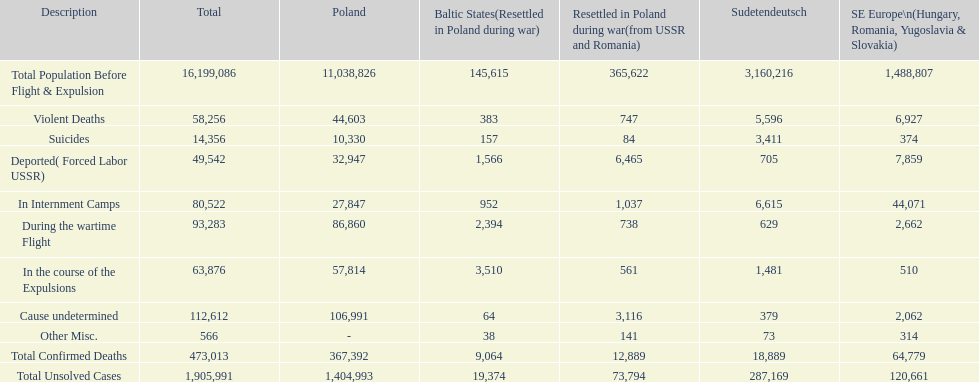Was there a larger total population before expulsion in poland or sudetendeutsch? Poland. 